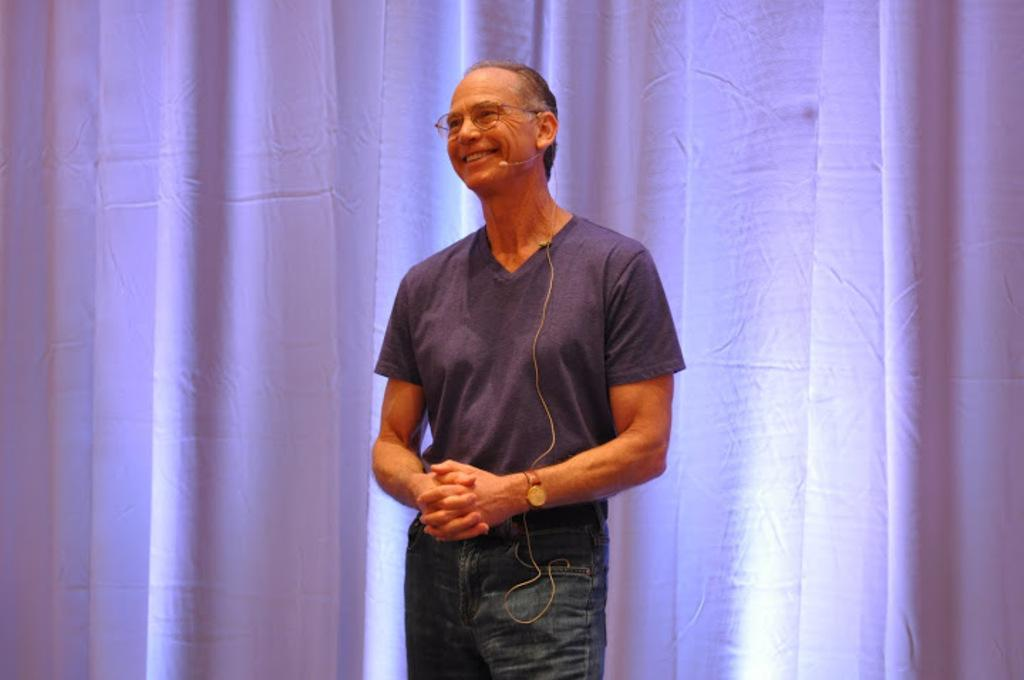Who is present in the image? There is a man in the image. What is the man's facial expression? The man is smiling. What accessory is the man wearing? The man is wearing spectacles. What object can be seen in the image that is typically used for amplifying sound? There is a microphone in the image. What type of window treatment is visible in the image? There are curtains in the image. What type of pan is being used to cook food in the image? There is no pan or cooking activity present in the image. How many crows are visible in the image? There are no crows present in the image. 